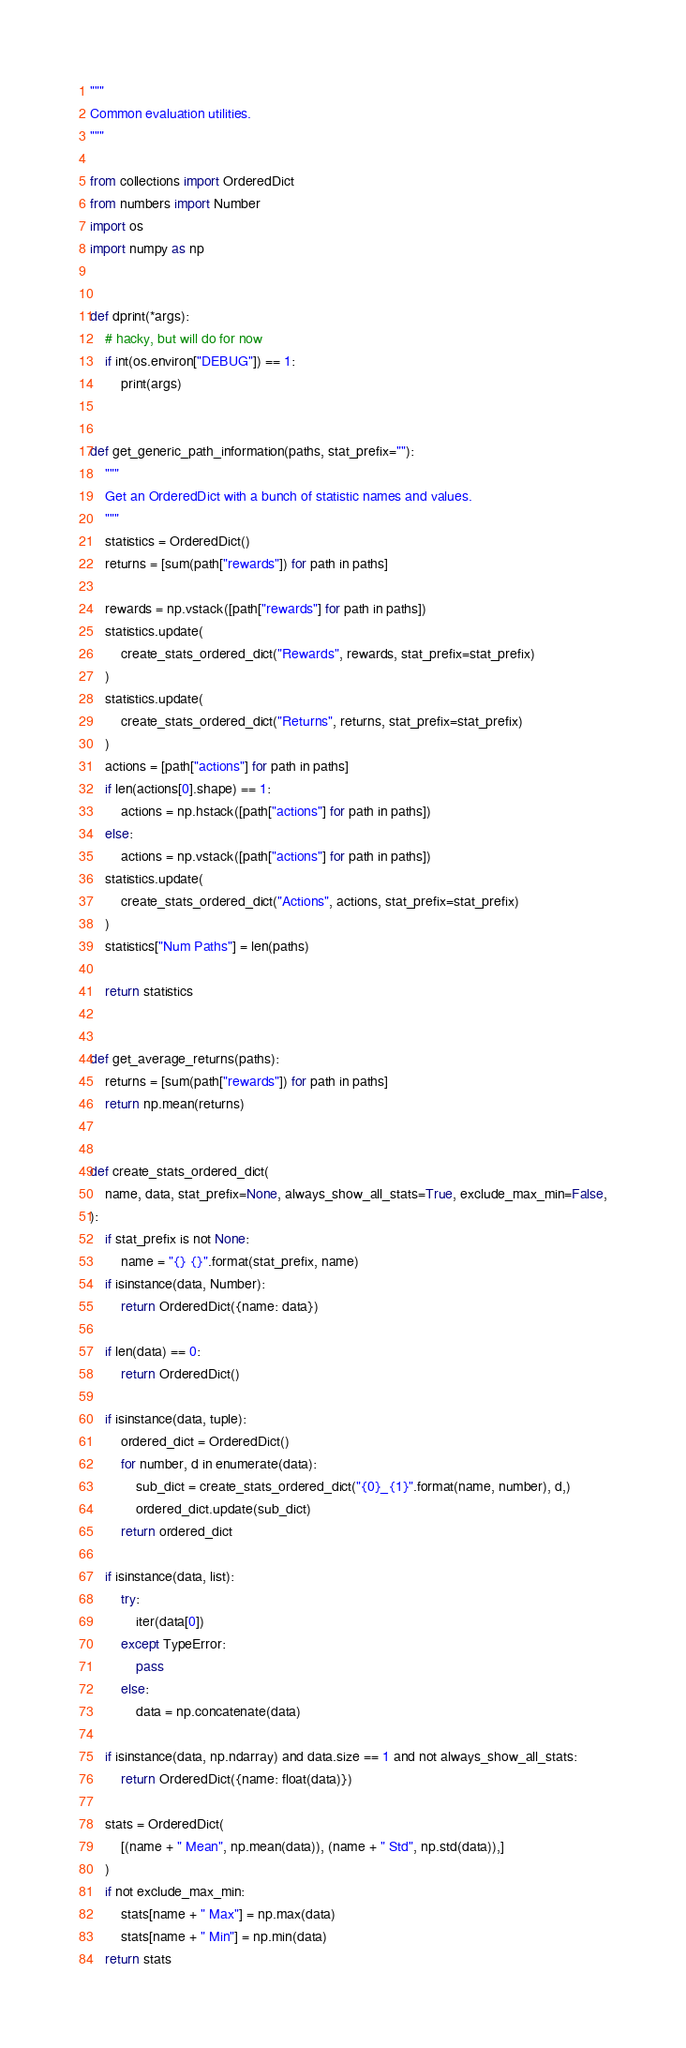Convert code to text. <code><loc_0><loc_0><loc_500><loc_500><_Python_>"""
Common evaluation utilities.
"""

from collections import OrderedDict
from numbers import Number
import os
import numpy as np


def dprint(*args):
    # hacky, but will do for now
    if int(os.environ["DEBUG"]) == 1:
        print(args)


def get_generic_path_information(paths, stat_prefix=""):
    """
    Get an OrderedDict with a bunch of statistic names and values.
    """
    statistics = OrderedDict()
    returns = [sum(path["rewards"]) for path in paths]

    rewards = np.vstack([path["rewards"] for path in paths])
    statistics.update(
        create_stats_ordered_dict("Rewards", rewards, stat_prefix=stat_prefix)
    )
    statistics.update(
        create_stats_ordered_dict("Returns", returns, stat_prefix=stat_prefix)
    )
    actions = [path["actions"] for path in paths]
    if len(actions[0].shape) == 1:
        actions = np.hstack([path["actions"] for path in paths])
    else:
        actions = np.vstack([path["actions"] for path in paths])
    statistics.update(
        create_stats_ordered_dict("Actions", actions, stat_prefix=stat_prefix)
    )
    statistics["Num Paths"] = len(paths)

    return statistics


def get_average_returns(paths):
    returns = [sum(path["rewards"]) for path in paths]
    return np.mean(returns)


def create_stats_ordered_dict(
    name, data, stat_prefix=None, always_show_all_stats=True, exclude_max_min=False,
):
    if stat_prefix is not None:
        name = "{} {}".format(stat_prefix, name)
    if isinstance(data, Number):
        return OrderedDict({name: data})

    if len(data) == 0:
        return OrderedDict()

    if isinstance(data, tuple):
        ordered_dict = OrderedDict()
        for number, d in enumerate(data):
            sub_dict = create_stats_ordered_dict("{0}_{1}".format(name, number), d,)
            ordered_dict.update(sub_dict)
        return ordered_dict

    if isinstance(data, list):
        try:
            iter(data[0])
        except TypeError:
            pass
        else:
            data = np.concatenate(data)

    if isinstance(data, np.ndarray) and data.size == 1 and not always_show_all_stats:
        return OrderedDict({name: float(data)})

    stats = OrderedDict(
        [(name + " Mean", np.mean(data)), (name + " Std", np.std(data)),]
    )
    if not exclude_max_min:
        stats[name + " Max"] = np.max(data)
        stats[name + " Min"] = np.min(data)
    return stats
</code> 